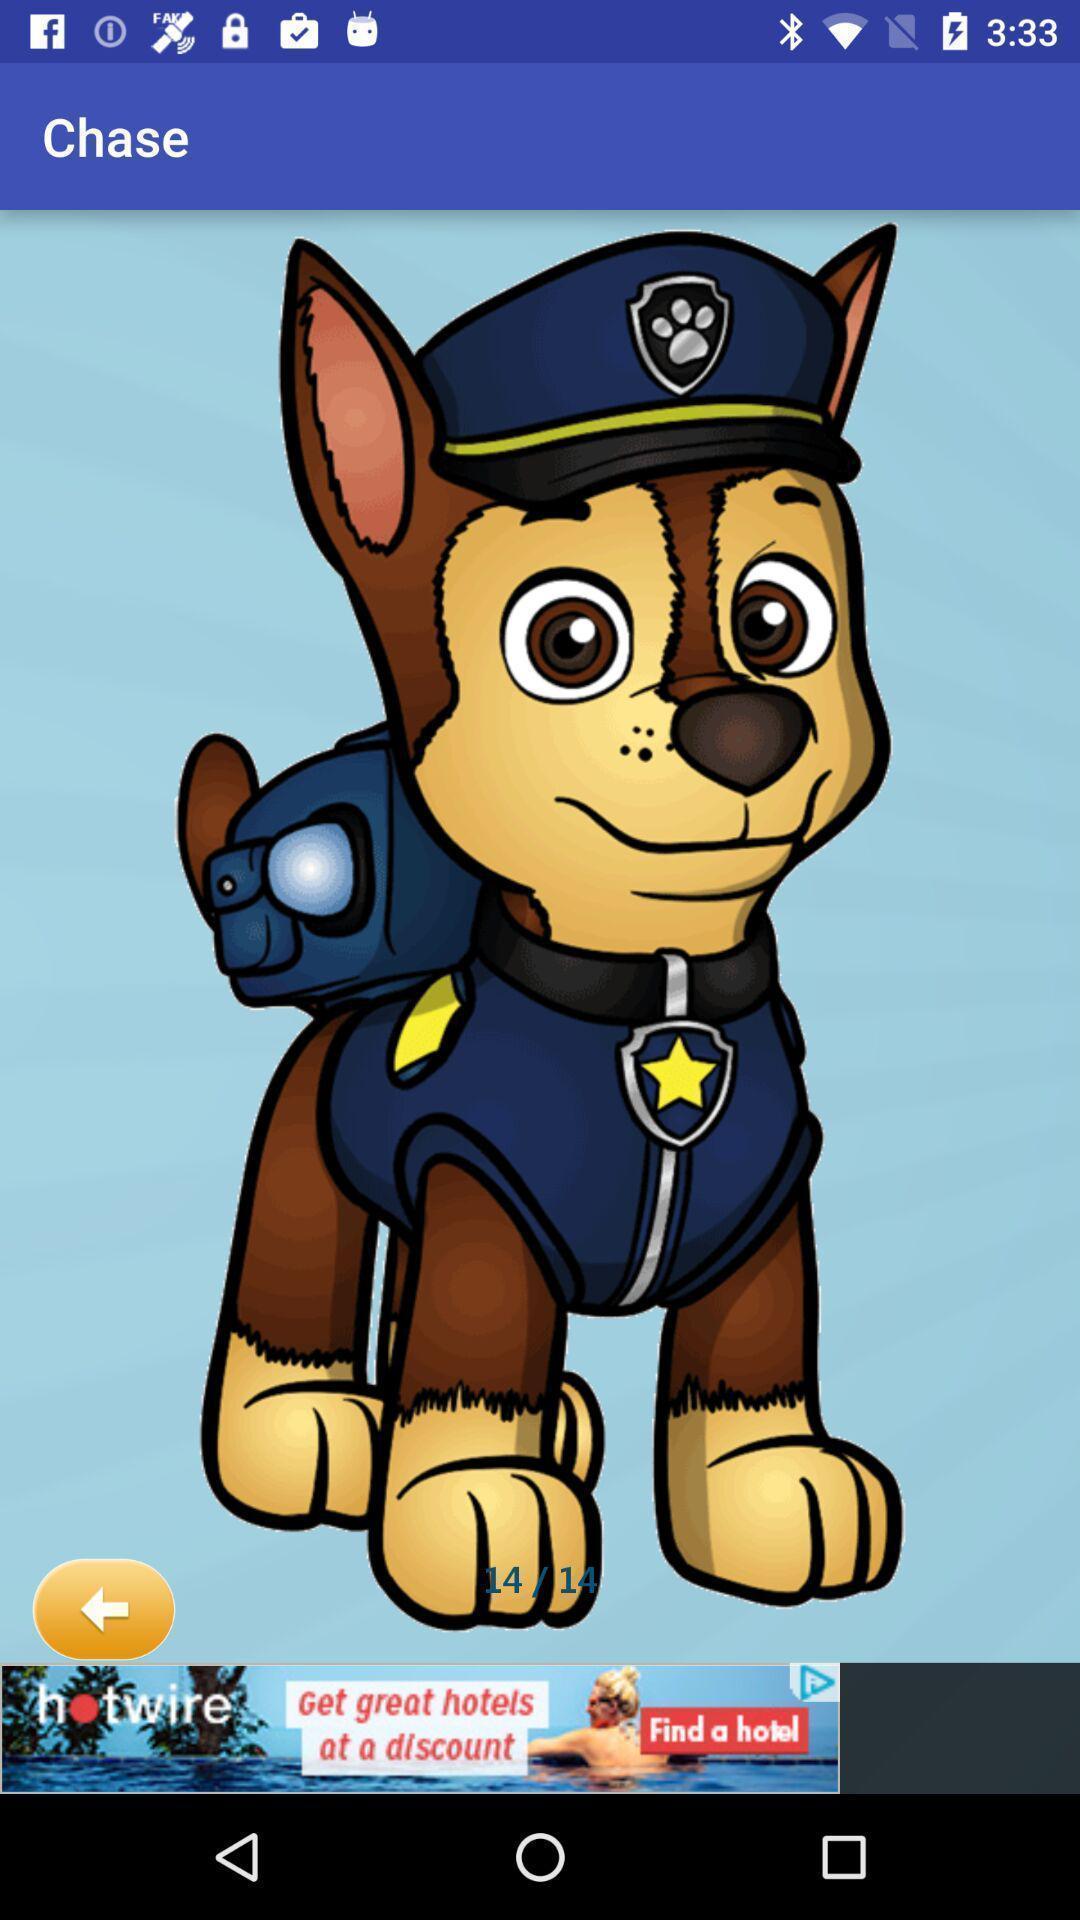What is the overall content of this screenshot? Page displaying dog cartoon image. 